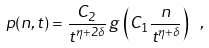Convert formula to latex. <formula><loc_0><loc_0><loc_500><loc_500>p ( n , t ) = \frac { C _ { 2 } } { t ^ { \eta + 2 \delta } } \, g \, \left ( C _ { 1 } \frac { n } { t ^ { \eta + \delta } } \right ) \ ,</formula> 